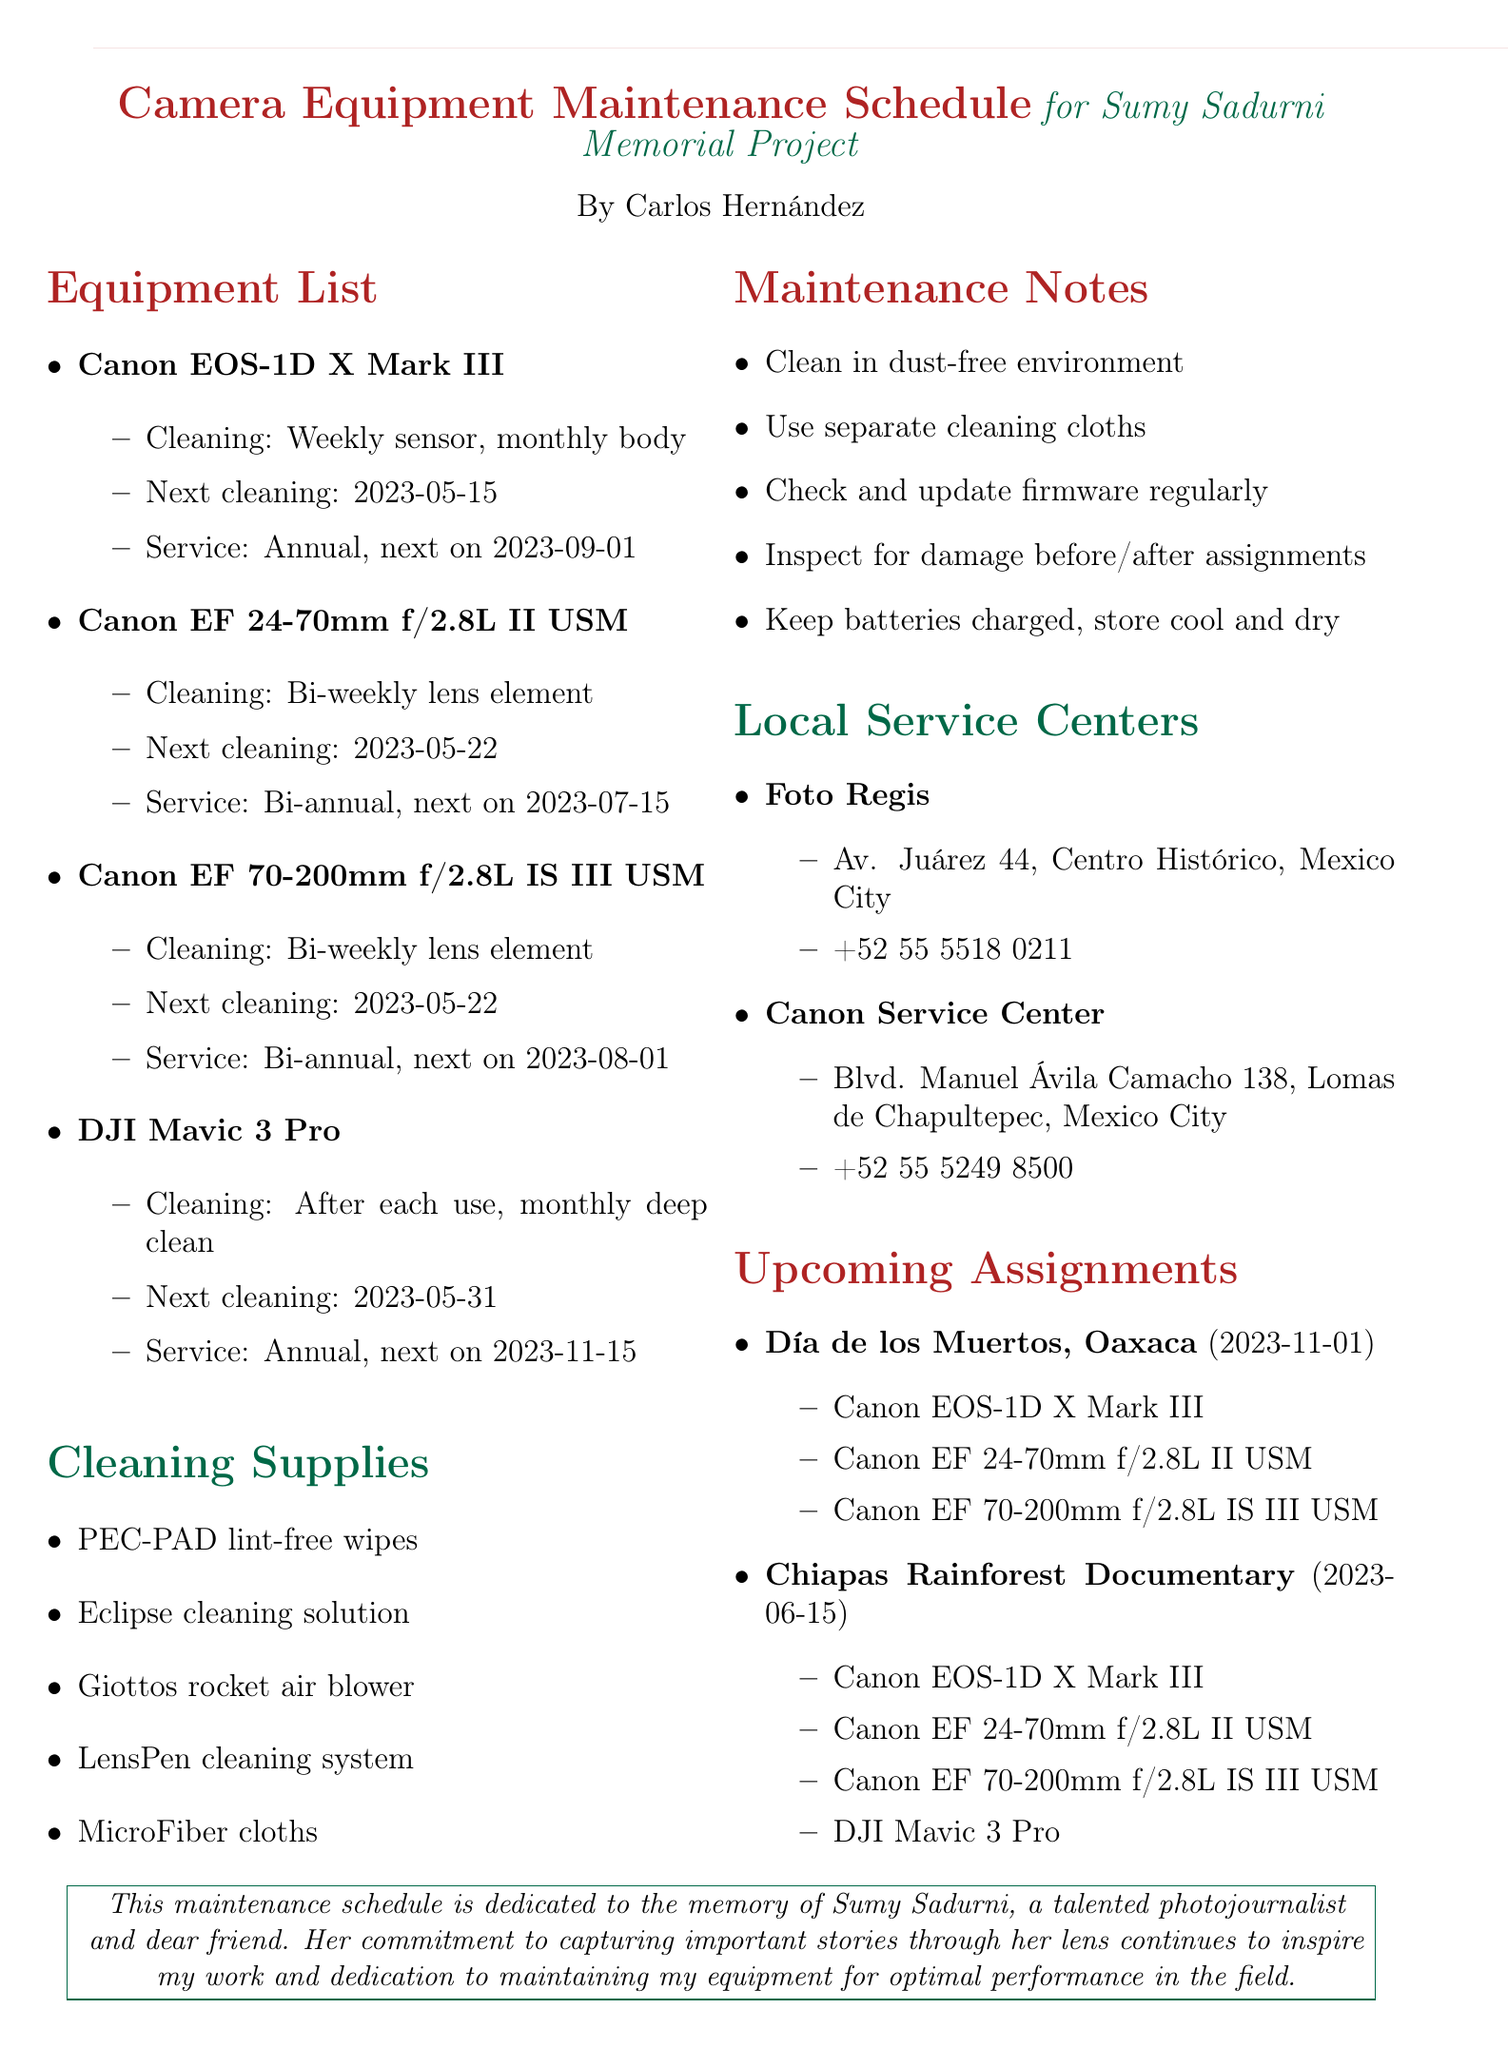What is the title of the memo? The title of the memo is found at the beginning of the document.
Answer: Camera Equipment Maintenance Schedule for Sumy Sadurni Memorial Project Who is the photographer's name? The photographer's name is listed under the memo title.
Answer: Carlos Hernández What is the next service date for the Canon EOS-1D X Mark III? The next service date can be found in the equipment list for that item.
Answer: 2023-09-01 How often should the DJI Mavic 3 Pro be cleaned? The cleaning frequency for the DJI Mavic 3 Pro is detailed in its maintenance section.
Answer: After each use, monthly deep clean Which cleaning supply is specifically mentioned for lint-free cleaning? The list of cleaning supplies includes various items, one of which is for lint-free use.
Answer: PEC-PAD lint-free wipes When is the upcoming assignment for the Día de los Muertos celebrations? The date for the upcoming assignment is listed in its respective section.
Answer: 2023-11-01 What service schedule is mentioned for the Canon EF 70-200mm f/2.8L IS III USM? The service schedule is specifically noted in the equipment list.
Answer: Bi-annual professional service Where is the Canon Service Center located? The address for the Canon Service Center can be found in the local service centers section.
Answer: Blvd. Manuel Ávila Camacho 138, Lomas de Chapultepec, Mexico City 